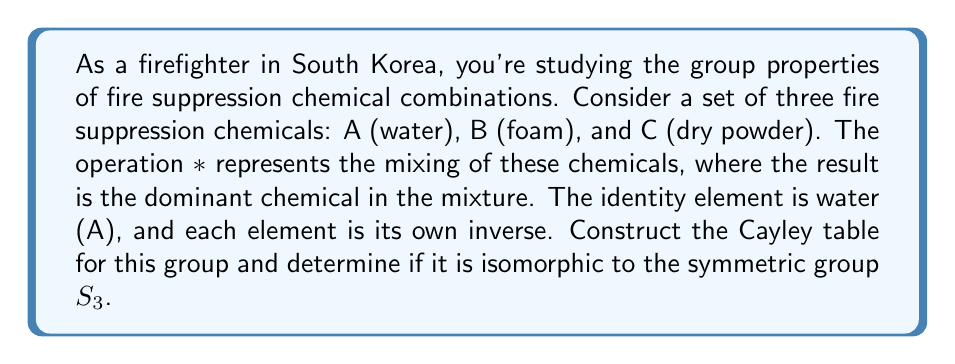Could you help me with this problem? Let's approach this step-by-step:

1) First, we need to construct the Cayley table for this group:

   $$
   \begin{array}{c|ccc}
   * & A & B & C \\
   \hline
   A & A & B & C \\
   B & B & A & C \\
   C & C & C & A
   \end{array}
   $$

2) To determine if this group is isomorphic to $S_3$, we need to check if it satisfies the same group properties:

   a) Both have 3 elements
   b) Both are non-abelian (AB ≠ BA in our group, just as in $S_3$)
   c) Both have one element of order 2 (B in our group) and two elements of order 3 (C and BC in our group)

3) We can establish a bijection between the elements:
   
   $A \leftrightarrow e$ (identity)
   $B \leftrightarrow (12)$
   $C \leftrightarrow (123)$

4) We can verify that this bijection preserves the group operation:

   $B * B = A$ corresponds to $(12) \circ (12) = e$
   $C * C * C = A$ corresponds to $(123) \circ (123) \circ (123) = e$
   $B * C = C * B = C$ corresponds to $(12) \circ (123) = (23) = (123) \circ (12)$

5) Since we have established a bijection that preserves the group operation, the two groups are indeed isomorphic.
Answer: Yes, the group of fire suppression chemical combinations is isomorphic to the symmetric group $S_3$. 